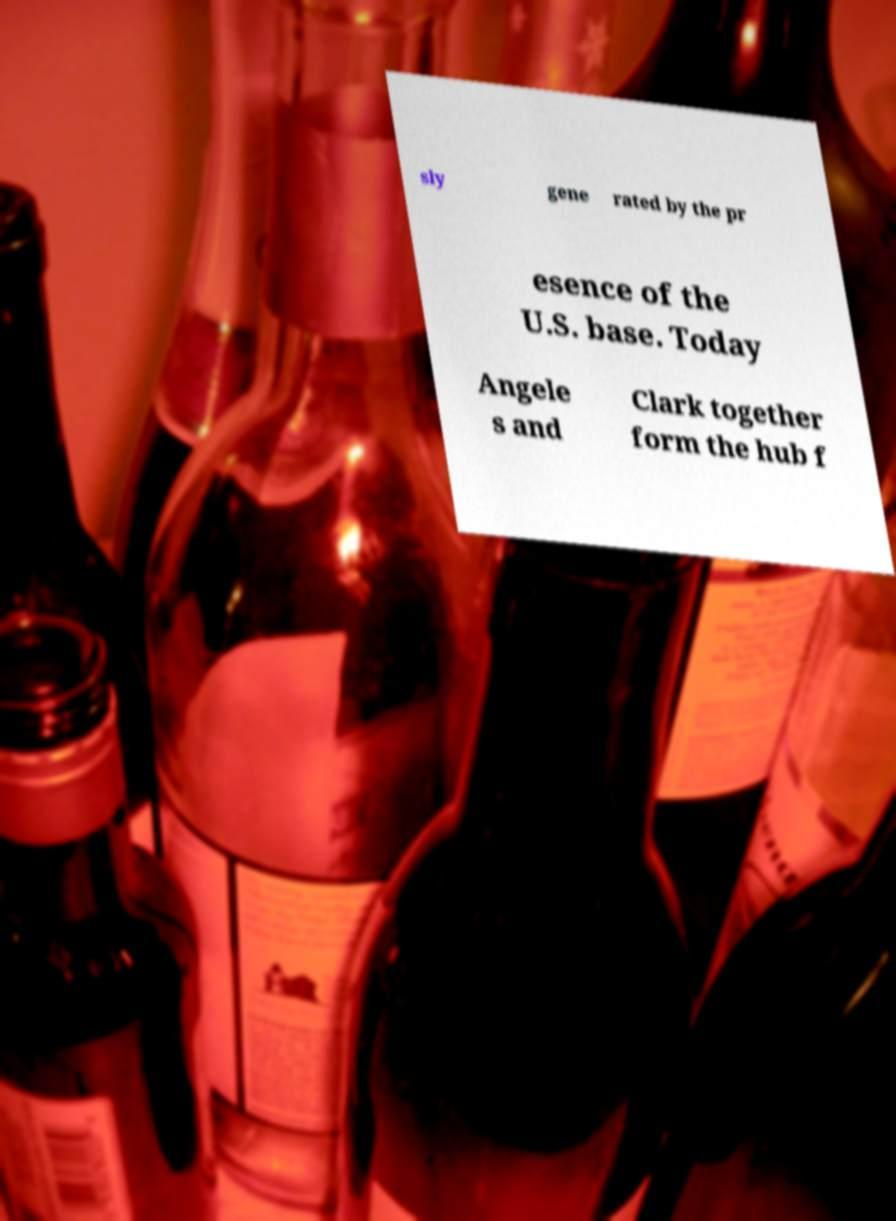Could you extract and type out the text from this image? sly gene rated by the pr esence of the U.S. base. Today Angele s and Clark together form the hub f 